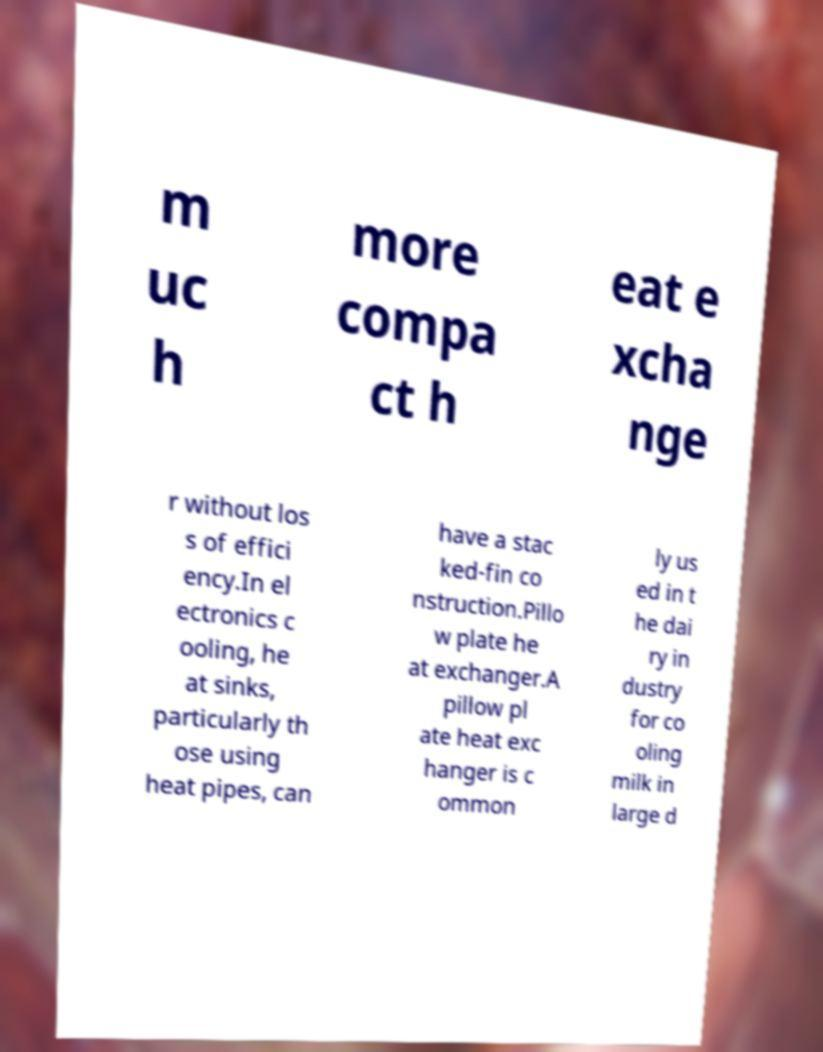There's text embedded in this image that I need extracted. Can you transcribe it verbatim? m uc h more compa ct h eat e xcha nge r without los s of effici ency.In el ectronics c ooling, he at sinks, particularly th ose using heat pipes, can have a stac ked-fin co nstruction.Pillo w plate he at exchanger.A pillow pl ate heat exc hanger is c ommon ly us ed in t he dai ry in dustry for co oling milk in large d 